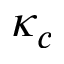<formula> <loc_0><loc_0><loc_500><loc_500>\kappa _ { c }</formula> 